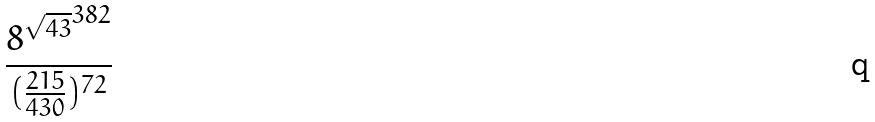<formula> <loc_0><loc_0><loc_500><loc_500>\frac { { 8 ^ { \sqrt { 4 3 } } } ^ { 3 8 2 } } { ( \frac { 2 1 5 } { 4 3 0 } ) ^ { 7 2 } }</formula> 